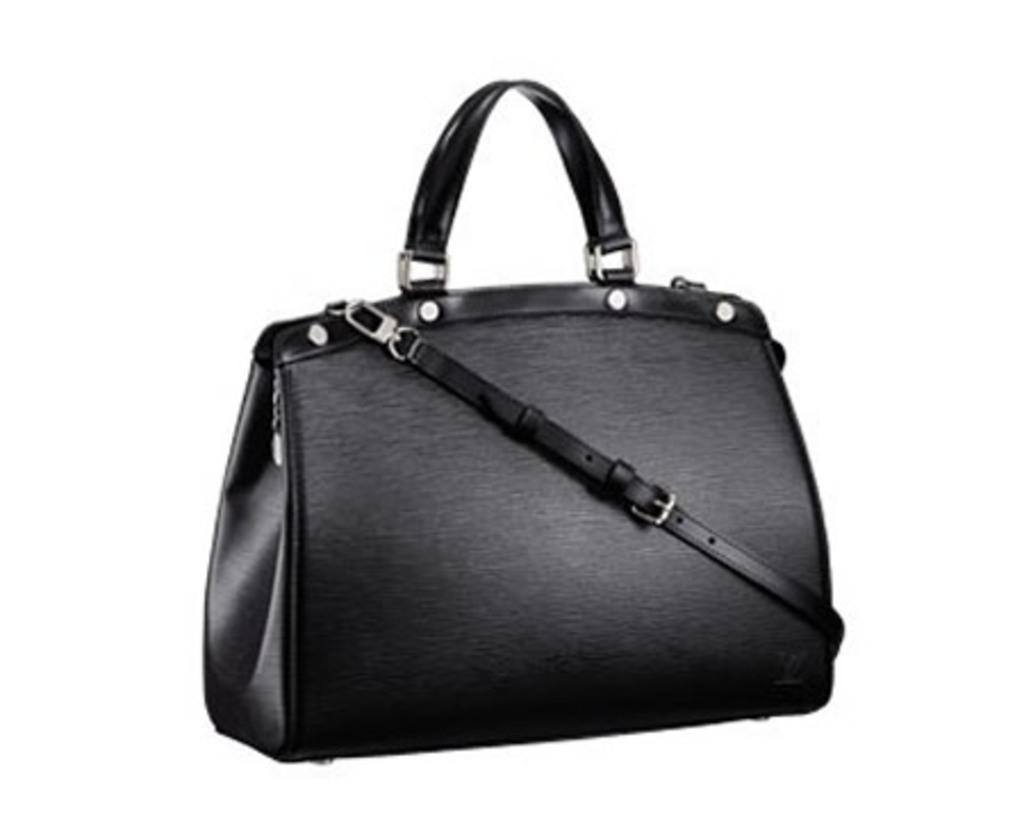Please provide a concise description of this image. In this image in the center there is one black handbag. 